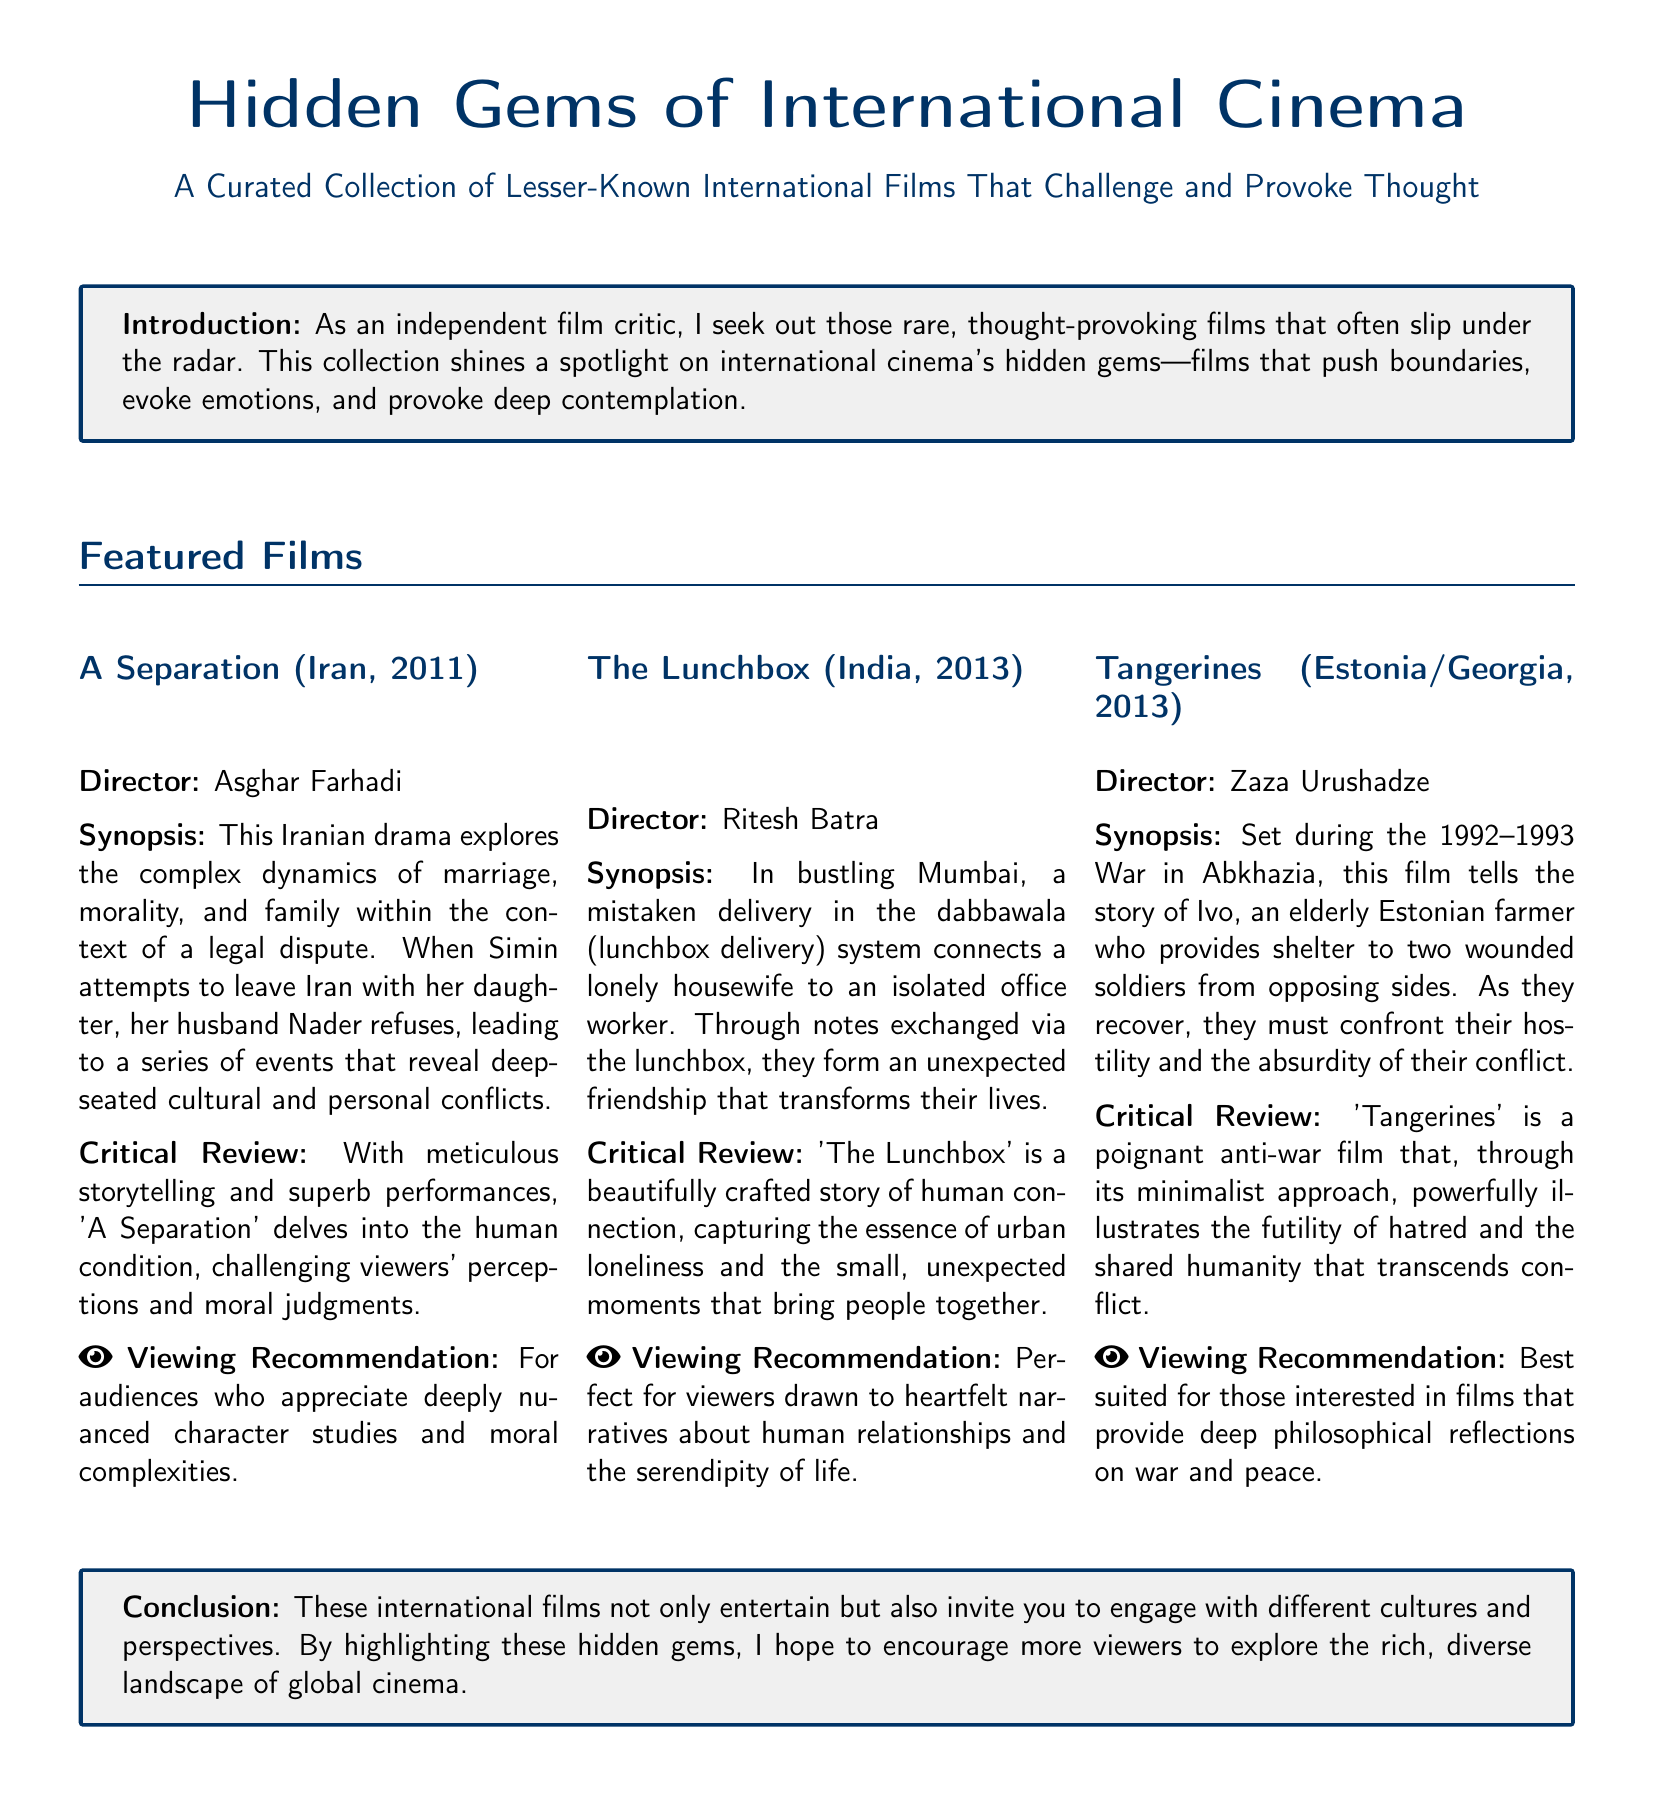What is the title of the featured collection? The title of the featured collection is mentioned prominently at the top of the document.
Answer: Hidden Gems of International Cinema Who directed "The Lunchbox"? This information is found under the film details for "The Lunchbox".
Answer: Ritesh Batra What year was "A Separation" released? The release year for "A Separation" is provided in its details.
Answer: 2011 How many films are featured in the document? The document lists three specific films.
Answer: Three What is the main theme of "Tangerines"? The theme of this film is summarized in its critical review.
Answer: Anti-war What does "The Lunchbox" explore? The synopsis describes the exploration of human connection and loneliness.
Answer: Human connection Which film is noted for challenging viewers’ moral judgments? The critical review highlights this aspect of one specific film.
Answer: A Separation Which director is mentioned for creating thought-provoking films? The introduction emphasizes seeking out rare films, indirectly highlighting filmmakers challenging norms.
Answer: Asghar Farhadi 